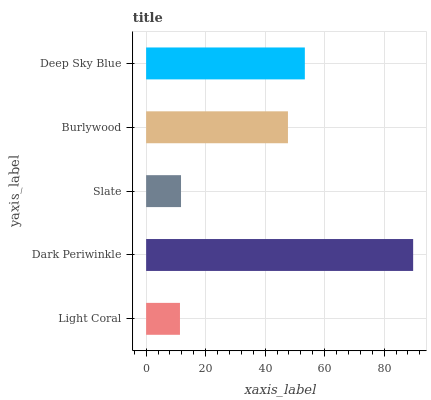Is Light Coral the minimum?
Answer yes or no. Yes. Is Dark Periwinkle the maximum?
Answer yes or no. Yes. Is Slate the minimum?
Answer yes or no. No. Is Slate the maximum?
Answer yes or no. No. Is Dark Periwinkle greater than Slate?
Answer yes or no. Yes. Is Slate less than Dark Periwinkle?
Answer yes or no. Yes. Is Slate greater than Dark Periwinkle?
Answer yes or no. No. Is Dark Periwinkle less than Slate?
Answer yes or no. No. Is Burlywood the high median?
Answer yes or no. Yes. Is Burlywood the low median?
Answer yes or no. Yes. Is Dark Periwinkle the high median?
Answer yes or no. No. Is Dark Periwinkle the low median?
Answer yes or no. No. 